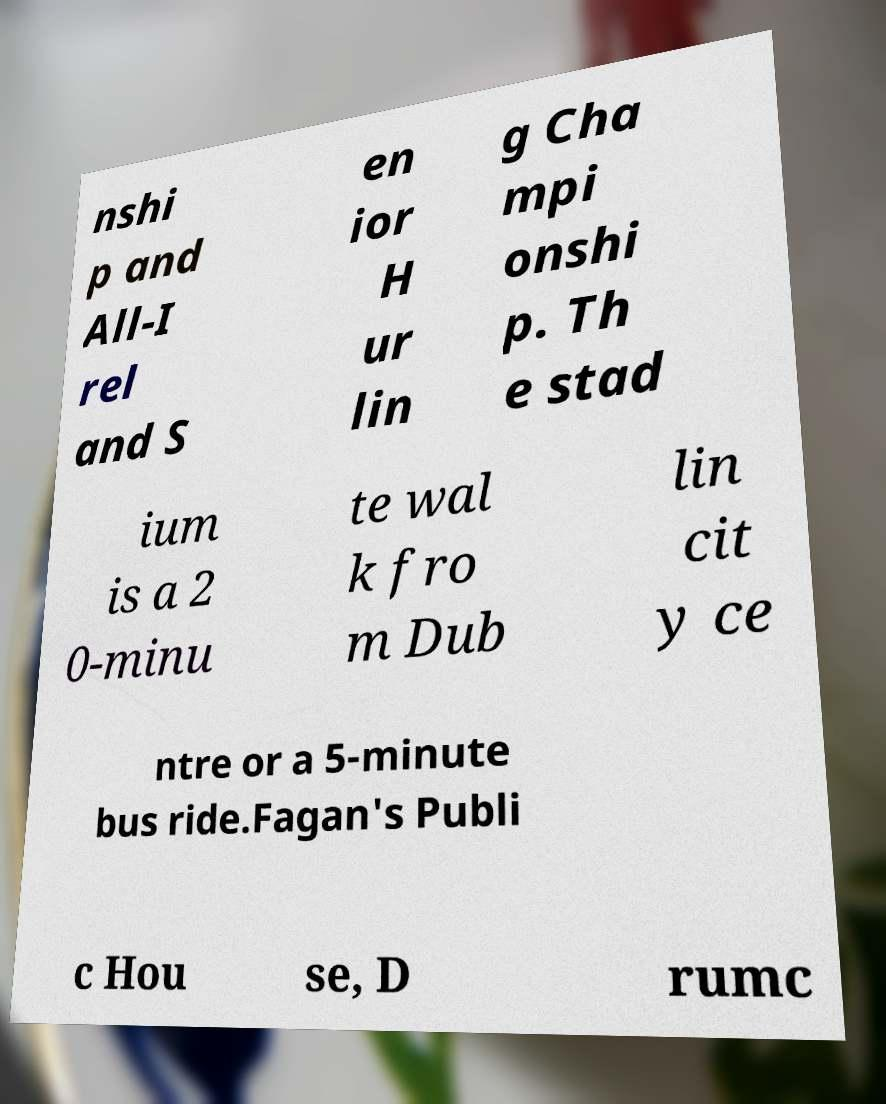Could you extract and type out the text from this image? nshi p and All-I rel and S en ior H ur lin g Cha mpi onshi p. Th e stad ium is a 2 0-minu te wal k fro m Dub lin cit y ce ntre or a 5-minute bus ride.Fagan's Publi c Hou se, D rumc 